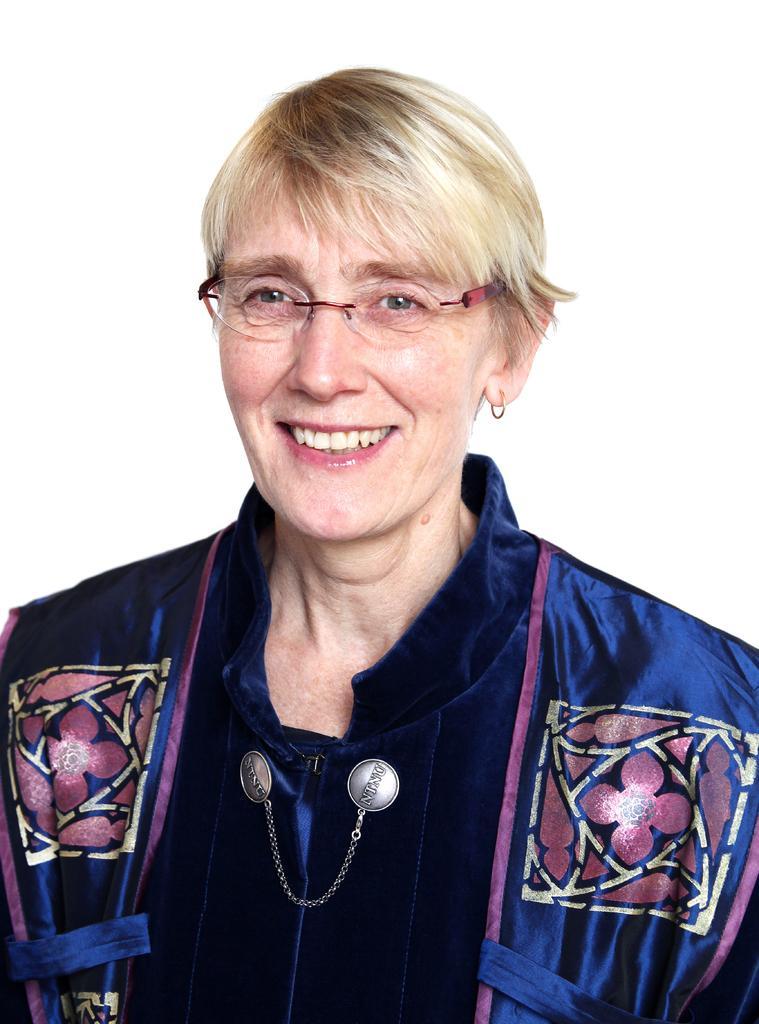Could you give a brief overview of what you see in this image? In this image there is a woman with a smile on her face. 